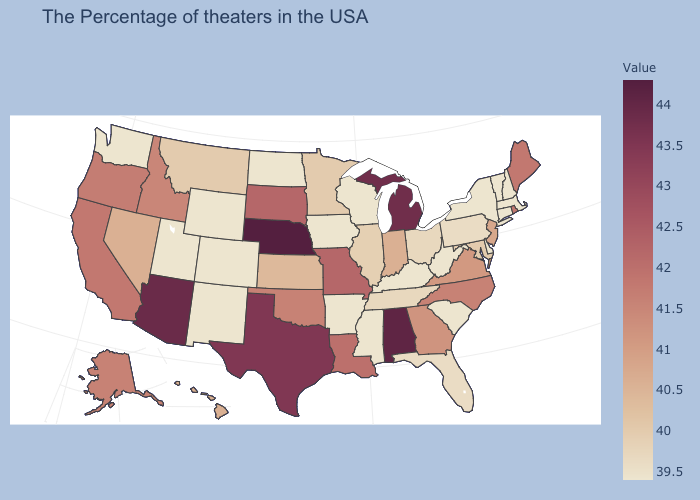Which states have the lowest value in the USA?
Keep it brief. Massachusetts, New Hampshire, Vermont, Connecticut, New York, Delaware, South Carolina, West Virginia, Kentucky, Wisconsin, Mississippi, Arkansas, Iowa, North Dakota, Wyoming, Colorado, New Mexico, Utah, Washington. Which states have the lowest value in the USA?
Quick response, please. Massachusetts, New Hampshire, Vermont, Connecticut, New York, Delaware, South Carolina, West Virginia, Kentucky, Wisconsin, Mississippi, Arkansas, Iowa, North Dakota, Wyoming, Colorado, New Mexico, Utah, Washington. Does Utah have the lowest value in the USA?
Answer briefly. Yes. Does Iowa have the lowest value in the MidWest?
Short answer required. Yes. Which states have the lowest value in the West?
Quick response, please. Wyoming, Colorado, New Mexico, Utah, Washington. 